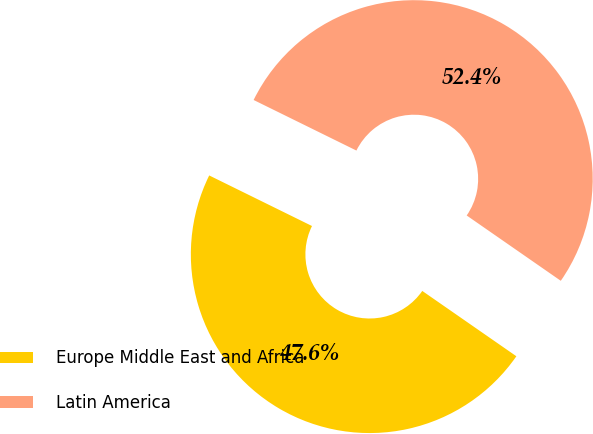Convert chart. <chart><loc_0><loc_0><loc_500><loc_500><pie_chart><fcel>Europe Middle East and Africa<fcel>Latin America<nl><fcel>47.62%<fcel>52.38%<nl></chart> 